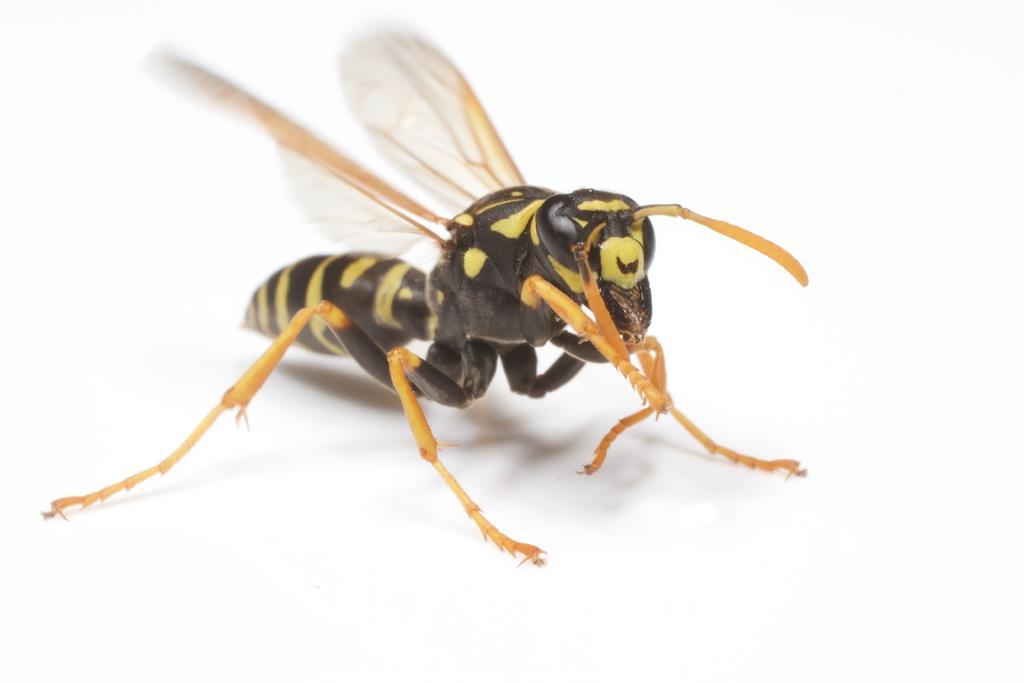How would you summarize this image in a sentence or two? In this image I can see a potter wasp on a white surface. 